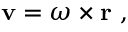<formula> <loc_0><loc_0><loc_500><loc_500>v = { \omega } \times r \ ,</formula> 